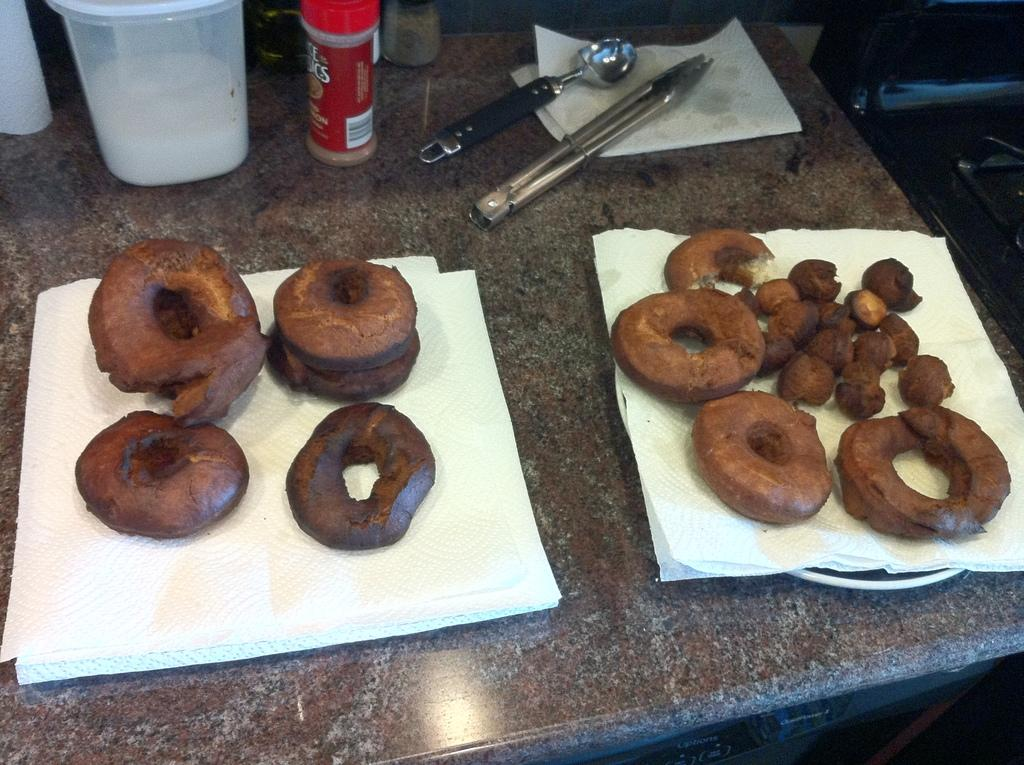What type of food is on the table in the image? There are doughnuts on the table in the image. What can be used for cleaning or wiping in the image? There are tissues on the table for cleaning or wiping. What can be used for serving or eating food in the image? There are plates on the table for serving or eating food. What can be used for storing or holding items in the image? There are jars and holders on the table for storing or holding items. What is visible in the background of the image? There is an object in the background of the image. What is the credit score of the person in the image? There is no person present in the image, and therefore no credit score can be determined. How many screws are visible in the image? There are no screws visible in the image. 